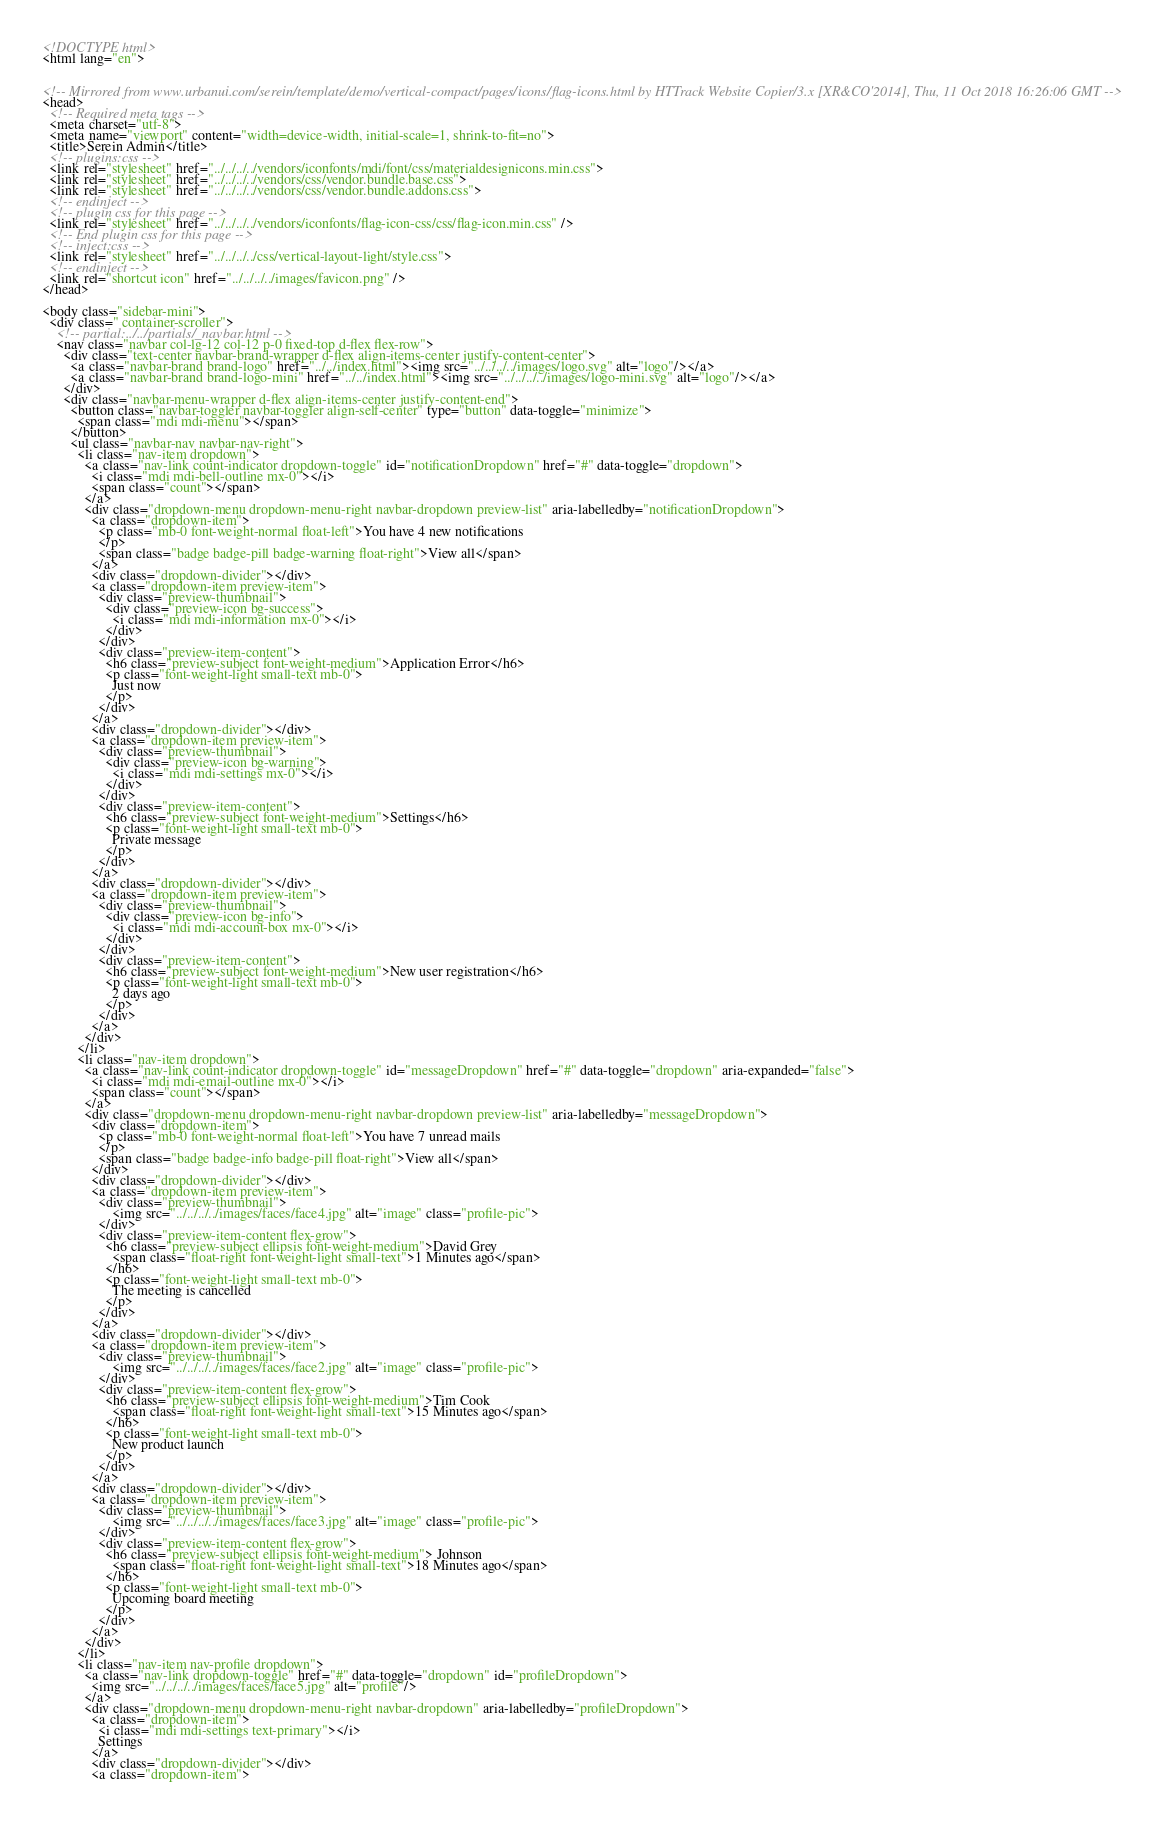Convert code to text. <code><loc_0><loc_0><loc_500><loc_500><_HTML_><!DOCTYPE html>
<html lang="en">


<!-- Mirrored from www.urbanui.com/serein/template/demo/vertical-compact/pages/icons/flag-icons.html by HTTrack Website Copier/3.x [XR&CO'2014], Thu, 11 Oct 2018 16:26:06 GMT -->
<head>
  <!-- Required meta tags -->
  <meta charset="utf-8">
  <meta name="viewport" content="width=device-width, initial-scale=1, shrink-to-fit=no">
  <title>Serein Admin</title>
  <!-- plugins:css -->
  <link rel="stylesheet" href="../../../../vendors/iconfonts/mdi/font/css/materialdesignicons.min.css">
  <link rel="stylesheet" href="../../../../vendors/css/vendor.bundle.base.css">
  <link rel="stylesheet" href="../../../../vendors/css/vendor.bundle.addons.css">
  <!-- endinject -->
  <!-- plugin css for this page -->
  <link rel="stylesheet" href="../../../../vendors/iconfonts/flag-icon-css/css/flag-icon.min.css" />
  <!-- End plugin css for this page -->
  <!-- inject:css -->
  <link rel="stylesheet" href="../../../../css/vertical-layout-light/style.css">
  <!-- endinject -->
  <link rel="shortcut icon" href="../../../../images/favicon.png" />
</head>

<body class="sidebar-mini">
  <div class=" container-scroller">
    <!-- partial:../../partials/_navbar.html -->
    <nav class="navbar col-lg-12 col-12 p-0 fixed-top d-flex flex-row">
      <div class="text-center navbar-brand-wrapper d-flex align-items-center justify-content-center">
        <a class="navbar-brand brand-logo" href="../../index.html"><img src="../../../../images/logo.svg" alt="logo"/></a>
        <a class="navbar-brand brand-logo-mini" href="../../index.html"><img src="../../../../images/logo-mini.svg" alt="logo"/></a>
      </div>
      <div class="navbar-menu-wrapper d-flex align-items-center justify-content-end">
        <button class="navbar-toggler navbar-toggler align-self-center" type="button" data-toggle="minimize">
          <span class="mdi mdi-menu"></span>
        </button>
        <ul class="navbar-nav navbar-nav-right">
          <li class="nav-item dropdown">
            <a class="nav-link count-indicator dropdown-toggle" id="notificationDropdown" href="#" data-toggle="dropdown">
              <i class="mdi mdi-bell-outline mx-0"></i>
              <span class="count"></span>
            </a>
            <div class="dropdown-menu dropdown-menu-right navbar-dropdown preview-list" aria-labelledby="notificationDropdown">
              <a class="dropdown-item">
                <p class="mb-0 font-weight-normal float-left">You have 4 new notifications
                </p>
                <span class="badge badge-pill badge-warning float-right">View all</span>
              </a>
              <div class="dropdown-divider"></div>
              <a class="dropdown-item preview-item">
                <div class="preview-thumbnail">
                  <div class="preview-icon bg-success">
                    <i class="mdi mdi-information mx-0"></i>
                  </div>
                </div>
                <div class="preview-item-content">
                  <h6 class="preview-subject font-weight-medium">Application Error</h6>
                  <p class="font-weight-light small-text mb-0">
                    Just now
                  </p>
                </div>
              </a>
              <div class="dropdown-divider"></div>
              <a class="dropdown-item preview-item">
                <div class="preview-thumbnail">
                  <div class="preview-icon bg-warning">
                    <i class="mdi mdi-settings mx-0"></i>
                  </div>
                </div>
                <div class="preview-item-content">
                  <h6 class="preview-subject font-weight-medium">Settings</h6>
                  <p class="font-weight-light small-text mb-0">
                    Private message
                  </p>
                </div>
              </a>
              <div class="dropdown-divider"></div>
              <a class="dropdown-item preview-item">
                <div class="preview-thumbnail">
                  <div class="preview-icon bg-info">
                    <i class="mdi mdi-account-box mx-0"></i>
                  </div>
                </div>
                <div class="preview-item-content">
                  <h6 class="preview-subject font-weight-medium">New user registration</h6>
                  <p class="font-weight-light small-text mb-0">
                    2 days ago
                  </p>
                </div>
              </a>
            </div>
          </li>
          <li class="nav-item dropdown">
            <a class="nav-link count-indicator dropdown-toggle" id="messageDropdown" href="#" data-toggle="dropdown" aria-expanded="false">
              <i class="mdi mdi-email-outline mx-0"></i>
              <span class="count"></span>
            </a>
            <div class="dropdown-menu dropdown-menu-right navbar-dropdown preview-list" aria-labelledby="messageDropdown">
              <div class="dropdown-item">
                <p class="mb-0 font-weight-normal float-left">You have 7 unread mails
                </p>
                <span class="badge badge-info badge-pill float-right">View all</span>
              </div>
              <div class="dropdown-divider"></div>
              <a class="dropdown-item preview-item">
                <div class="preview-thumbnail">
                    <img src="../../../../images/faces/face4.jpg" alt="image" class="profile-pic">
                </div>
                <div class="preview-item-content flex-grow">
                  <h6 class="preview-subject ellipsis font-weight-medium">David Grey
                    <span class="float-right font-weight-light small-text">1 Minutes ago</span>
                  </h6>
                  <p class="font-weight-light small-text mb-0">
                    The meeting is cancelled
                  </p>
                </div>
              </a>
              <div class="dropdown-divider"></div>
              <a class="dropdown-item preview-item">
                <div class="preview-thumbnail">
                    <img src="../../../../images/faces/face2.jpg" alt="image" class="profile-pic">
                </div>
                <div class="preview-item-content flex-grow">
                  <h6 class="preview-subject ellipsis font-weight-medium">Tim Cook
                    <span class="float-right font-weight-light small-text">15 Minutes ago</span>
                  </h6>
                  <p class="font-weight-light small-text mb-0">
                    New product launch
                  </p>
                </div>
              </a>
              <div class="dropdown-divider"></div>
              <a class="dropdown-item preview-item">
                <div class="preview-thumbnail">
                    <img src="../../../../images/faces/face3.jpg" alt="image" class="profile-pic">
                </div>
                <div class="preview-item-content flex-grow">
                  <h6 class="preview-subject ellipsis font-weight-medium"> Johnson
                    <span class="float-right font-weight-light small-text">18 Minutes ago</span>
                  </h6>
                  <p class="font-weight-light small-text mb-0">
                    Upcoming board meeting
                  </p>
                </div>
              </a>
            </div>
          </li>
          <li class="nav-item nav-profile dropdown">
            <a class="nav-link dropdown-toggle" href="#" data-toggle="dropdown" id="profileDropdown">
              <img src="../../../../images/faces/face5.jpg" alt="profile"/>
            </a>
            <div class="dropdown-menu dropdown-menu-right navbar-dropdown" aria-labelledby="profileDropdown">
              <a class="dropdown-item">
                <i class="mdi mdi-settings text-primary"></i>
                Settings
              </a>
              <div class="dropdown-divider"></div>
              <a class="dropdown-item"></code> 